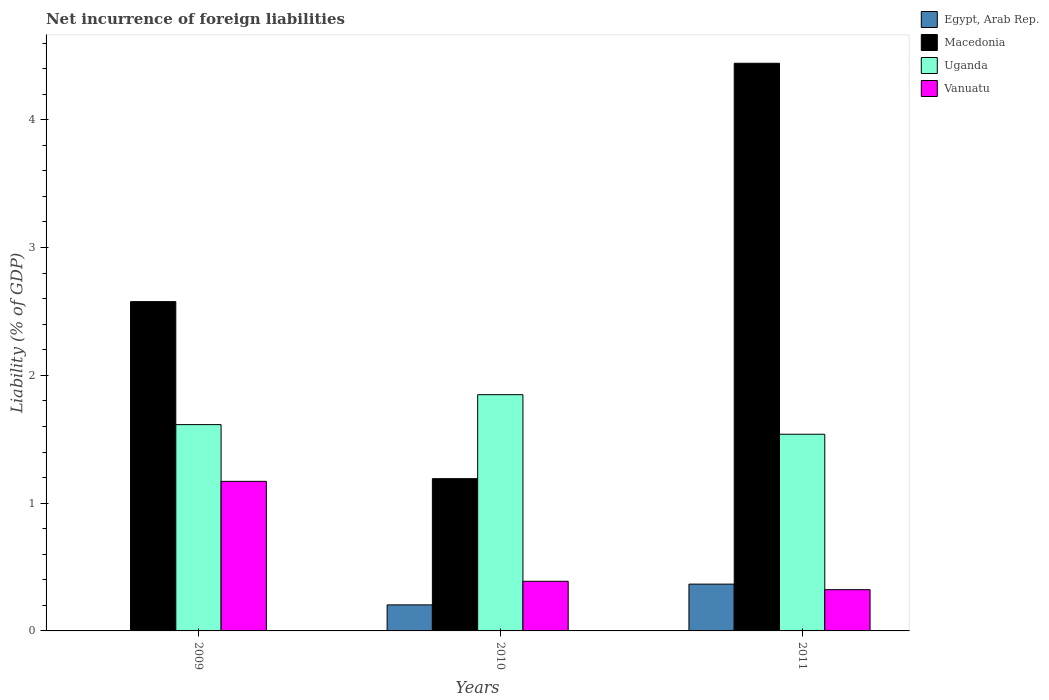How many groups of bars are there?
Offer a terse response. 3. How many bars are there on the 1st tick from the left?
Offer a terse response. 3. How many bars are there on the 3rd tick from the right?
Ensure brevity in your answer.  3. What is the label of the 3rd group of bars from the left?
Make the answer very short. 2011. What is the net incurrence of foreign liabilities in Vanuatu in 2011?
Give a very brief answer. 0.32. Across all years, what is the maximum net incurrence of foreign liabilities in Uganda?
Make the answer very short. 1.85. Across all years, what is the minimum net incurrence of foreign liabilities in Vanuatu?
Make the answer very short. 0.32. In which year was the net incurrence of foreign liabilities in Macedonia maximum?
Provide a short and direct response. 2011. What is the total net incurrence of foreign liabilities in Vanuatu in the graph?
Your response must be concise. 1.88. What is the difference between the net incurrence of foreign liabilities in Uganda in 2009 and that in 2010?
Ensure brevity in your answer.  -0.23. What is the difference between the net incurrence of foreign liabilities in Uganda in 2011 and the net incurrence of foreign liabilities in Vanuatu in 2009?
Provide a short and direct response. 0.37. What is the average net incurrence of foreign liabilities in Vanuatu per year?
Offer a very short reply. 0.63. In the year 2011, what is the difference between the net incurrence of foreign liabilities in Egypt, Arab Rep. and net incurrence of foreign liabilities in Macedonia?
Give a very brief answer. -4.08. In how many years, is the net incurrence of foreign liabilities in Vanuatu greater than 0.6000000000000001 %?
Give a very brief answer. 1. What is the ratio of the net incurrence of foreign liabilities in Vanuatu in 2010 to that in 2011?
Your response must be concise. 1.2. Is the net incurrence of foreign liabilities in Egypt, Arab Rep. in 2010 less than that in 2011?
Your answer should be compact. Yes. What is the difference between the highest and the second highest net incurrence of foreign liabilities in Vanuatu?
Give a very brief answer. 0.78. What is the difference between the highest and the lowest net incurrence of foreign liabilities in Egypt, Arab Rep.?
Your answer should be compact. 0.37. Is the sum of the net incurrence of foreign liabilities in Uganda in 2010 and 2011 greater than the maximum net incurrence of foreign liabilities in Vanuatu across all years?
Offer a very short reply. Yes. Is it the case that in every year, the sum of the net incurrence of foreign liabilities in Uganda and net incurrence of foreign liabilities in Macedonia is greater than the net incurrence of foreign liabilities in Egypt, Arab Rep.?
Provide a succinct answer. Yes. How many bars are there?
Offer a terse response. 11. How many years are there in the graph?
Offer a very short reply. 3. What is the difference between two consecutive major ticks on the Y-axis?
Ensure brevity in your answer.  1. Does the graph contain any zero values?
Your answer should be very brief. Yes. How many legend labels are there?
Your response must be concise. 4. What is the title of the graph?
Your response must be concise. Net incurrence of foreign liabilities. Does "Uzbekistan" appear as one of the legend labels in the graph?
Give a very brief answer. No. What is the label or title of the Y-axis?
Give a very brief answer. Liability (% of GDP). What is the Liability (% of GDP) in Egypt, Arab Rep. in 2009?
Keep it short and to the point. 0. What is the Liability (% of GDP) in Macedonia in 2009?
Your answer should be very brief. 2.58. What is the Liability (% of GDP) of Uganda in 2009?
Make the answer very short. 1.61. What is the Liability (% of GDP) of Vanuatu in 2009?
Ensure brevity in your answer.  1.17. What is the Liability (% of GDP) in Egypt, Arab Rep. in 2010?
Make the answer very short. 0.2. What is the Liability (% of GDP) in Macedonia in 2010?
Your response must be concise. 1.19. What is the Liability (% of GDP) of Uganda in 2010?
Your answer should be compact. 1.85. What is the Liability (% of GDP) of Vanuatu in 2010?
Provide a short and direct response. 0.39. What is the Liability (% of GDP) of Egypt, Arab Rep. in 2011?
Offer a terse response. 0.37. What is the Liability (% of GDP) of Macedonia in 2011?
Your answer should be compact. 4.44. What is the Liability (% of GDP) in Uganda in 2011?
Give a very brief answer. 1.54. What is the Liability (% of GDP) of Vanuatu in 2011?
Your answer should be very brief. 0.32. Across all years, what is the maximum Liability (% of GDP) of Egypt, Arab Rep.?
Provide a succinct answer. 0.37. Across all years, what is the maximum Liability (% of GDP) in Macedonia?
Provide a succinct answer. 4.44. Across all years, what is the maximum Liability (% of GDP) in Uganda?
Offer a terse response. 1.85. Across all years, what is the maximum Liability (% of GDP) of Vanuatu?
Your answer should be very brief. 1.17. Across all years, what is the minimum Liability (% of GDP) in Macedonia?
Offer a terse response. 1.19. Across all years, what is the minimum Liability (% of GDP) in Uganda?
Offer a terse response. 1.54. Across all years, what is the minimum Liability (% of GDP) of Vanuatu?
Offer a terse response. 0.32. What is the total Liability (% of GDP) in Egypt, Arab Rep. in the graph?
Your answer should be compact. 0.57. What is the total Liability (% of GDP) in Macedonia in the graph?
Provide a short and direct response. 8.21. What is the total Liability (% of GDP) of Uganda in the graph?
Ensure brevity in your answer.  5. What is the total Liability (% of GDP) in Vanuatu in the graph?
Offer a very short reply. 1.88. What is the difference between the Liability (% of GDP) in Macedonia in 2009 and that in 2010?
Offer a terse response. 1.39. What is the difference between the Liability (% of GDP) of Uganda in 2009 and that in 2010?
Provide a short and direct response. -0.23. What is the difference between the Liability (% of GDP) in Vanuatu in 2009 and that in 2010?
Offer a very short reply. 0.78. What is the difference between the Liability (% of GDP) of Macedonia in 2009 and that in 2011?
Your answer should be compact. -1.87. What is the difference between the Liability (% of GDP) in Uganda in 2009 and that in 2011?
Your answer should be compact. 0.08. What is the difference between the Liability (% of GDP) in Vanuatu in 2009 and that in 2011?
Your answer should be compact. 0.85. What is the difference between the Liability (% of GDP) in Egypt, Arab Rep. in 2010 and that in 2011?
Keep it short and to the point. -0.16. What is the difference between the Liability (% of GDP) of Macedonia in 2010 and that in 2011?
Make the answer very short. -3.25. What is the difference between the Liability (% of GDP) in Uganda in 2010 and that in 2011?
Your response must be concise. 0.31. What is the difference between the Liability (% of GDP) in Vanuatu in 2010 and that in 2011?
Your answer should be very brief. 0.07. What is the difference between the Liability (% of GDP) of Macedonia in 2009 and the Liability (% of GDP) of Uganda in 2010?
Offer a very short reply. 0.73. What is the difference between the Liability (% of GDP) in Macedonia in 2009 and the Liability (% of GDP) in Vanuatu in 2010?
Provide a short and direct response. 2.19. What is the difference between the Liability (% of GDP) of Uganda in 2009 and the Liability (% of GDP) of Vanuatu in 2010?
Provide a succinct answer. 1.23. What is the difference between the Liability (% of GDP) in Macedonia in 2009 and the Liability (% of GDP) in Uganda in 2011?
Your answer should be compact. 1.04. What is the difference between the Liability (% of GDP) of Macedonia in 2009 and the Liability (% of GDP) of Vanuatu in 2011?
Provide a succinct answer. 2.25. What is the difference between the Liability (% of GDP) of Uganda in 2009 and the Liability (% of GDP) of Vanuatu in 2011?
Keep it short and to the point. 1.29. What is the difference between the Liability (% of GDP) in Egypt, Arab Rep. in 2010 and the Liability (% of GDP) in Macedonia in 2011?
Ensure brevity in your answer.  -4.24. What is the difference between the Liability (% of GDP) of Egypt, Arab Rep. in 2010 and the Liability (% of GDP) of Uganda in 2011?
Your response must be concise. -1.34. What is the difference between the Liability (% of GDP) in Egypt, Arab Rep. in 2010 and the Liability (% of GDP) in Vanuatu in 2011?
Offer a terse response. -0.12. What is the difference between the Liability (% of GDP) in Macedonia in 2010 and the Liability (% of GDP) in Uganda in 2011?
Your answer should be very brief. -0.35. What is the difference between the Liability (% of GDP) in Macedonia in 2010 and the Liability (% of GDP) in Vanuatu in 2011?
Keep it short and to the point. 0.87. What is the difference between the Liability (% of GDP) in Uganda in 2010 and the Liability (% of GDP) in Vanuatu in 2011?
Your response must be concise. 1.53. What is the average Liability (% of GDP) of Egypt, Arab Rep. per year?
Provide a short and direct response. 0.19. What is the average Liability (% of GDP) of Macedonia per year?
Provide a short and direct response. 2.74. What is the average Liability (% of GDP) of Uganda per year?
Offer a terse response. 1.67. What is the average Liability (% of GDP) in Vanuatu per year?
Provide a short and direct response. 0.63. In the year 2009, what is the difference between the Liability (% of GDP) in Macedonia and Liability (% of GDP) in Uganda?
Your answer should be very brief. 0.96. In the year 2009, what is the difference between the Liability (% of GDP) of Macedonia and Liability (% of GDP) of Vanuatu?
Give a very brief answer. 1.41. In the year 2009, what is the difference between the Liability (% of GDP) in Uganda and Liability (% of GDP) in Vanuatu?
Provide a short and direct response. 0.44. In the year 2010, what is the difference between the Liability (% of GDP) in Egypt, Arab Rep. and Liability (% of GDP) in Macedonia?
Ensure brevity in your answer.  -0.99. In the year 2010, what is the difference between the Liability (% of GDP) of Egypt, Arab Rep. and Liability (% of GDP) of Uganda?
Your answer should be compact. -1.64. In the year 2010, what is the difference between the Liability (% of GDP) of Egypt, Arab Rep. and Liability (% of GDP) of Vanuatu?
Your answer should be compact. -0.18. In the year 2010, what is the difference between the Liability (% of GDP) of Macedonia and Liability (% of GDP) of Uganda?
Your answer should be very brief. -0.66. In the year 2010, what is the difference between the Liability (% of GDP) in Macedonia and Liability (% of GDP) in Vanuatu?
Your answer should be compact. 0.8. In the year 2010, what is the difference between the Liability (% of GDP) in Uganda and Liability (% of GDP) in Vanuatu?
Provide a short and direct response. 1.46. In the year 2011, what is the difference between the Liability (% of GDP) in Egypt, Arab Rep. and Liability (% of GDP) in Macedonia?
Keep it short and to the point. -4.08. In the year 2011, what is the difference between the Liability (% of GDP) of Egypt, Arab Rep. and Liability (% of GDP) of Uganda?
Your answer should be compact. -1.17. In the year 2011, what is the difference between the Liability (% of GDP) in Egypt, Arab Rep. and Liability (% of GDP) in Vanuatu?
Your response must be concise. 0.04. In the year 2011, what is the difference between the Liability (% of GDP) of Macedonia and Liability (% of GDP) of Uganda?
Provide a succinct answer. 2.9. In the year 2011, what is the difference between the Liability (% of GDP) of Macedonia and Liability (% of GDP) of Vanuatu?
Ensure brevity in your answer.  4.12. In the year 2011, what is the difference between the Liability (% of GDP) of Uganda and Liability (% of GDP) of Vanuatu?
Ensure brevity in your answer.  1.22. What is the ratio of the Liability (% of GDP) of Macedonia in 2009 to that in 2010?
Make the answer very short. 2.16. What is the ratio of the Liability (% of GDP) of Uganda in 2009 to that in 2010?
Your response must be concise. 0.87. What is the ratio of the Liability (% of GDP) of Vanuatu in 2009 to that in 2010?
Provide a short and direct response. 3.01. What is the ratio of the Liability (% of GDP) of Macedonia in 2009 to that in 2011?
Offer a terse response. 0.58. What is the ratio of the Liability (% of GDP) in Uganda in 2009 to that in 2011?
Keep it short and to the point. 1.05. What is the ratio of the Liability (% of GDP) in Vanuatu in 2009 to that in 2011?
Ensure brevity in your answer.  3.63. What is the ratio of the Liability (% of GDP) in Egypt, Arab Rep. in 2010 to that in 2011?
Your answer should be compact. 0.56. What is the ratio of the Liability (% of GDP) in Macedonia in 2010 to that in 2011?
Provide a short and direct response. 0.27. What is the ratio of the Liability (% of GDP) in Uganda in 2010 to that in 2011?
Your answer should be very brief. 1.2. What is the ratio of the Liability (% of GDP) in Vanuatu in 2010 to that in 2011?
Provide a short and direct response. 1.2. What is the difference between the highest and the second highest Liability (% of GDP) in Macedonia?
Provide a succinct answer. 1.87. What is the difference between the highest and the second highest Liability (% of GDP) in Uganda?
Make the answer very short. 0.23. What is the difference between the highest and the second highest Liability (% of GDP) of Vanuatu?
Provide a succinct answer. 0.78. What is the difference between the highest and the lowest Liability (% of GDP) of Egypt, Arab Rep.?
Give a very brief answer. 0.37. What is the difference between the highest and the lowest Liability (% of GDP) of Macedonia?
Your answer should be compact. 3.25. What is the difference between the highest and the lowest Liability (% of GDP) of Uganda?
Keep it short and to the point. 0.31. What is the difference between the highest and the lowest Liability (% of GDP) of Vanuatu?
Your answer should be compact. 0.85. 